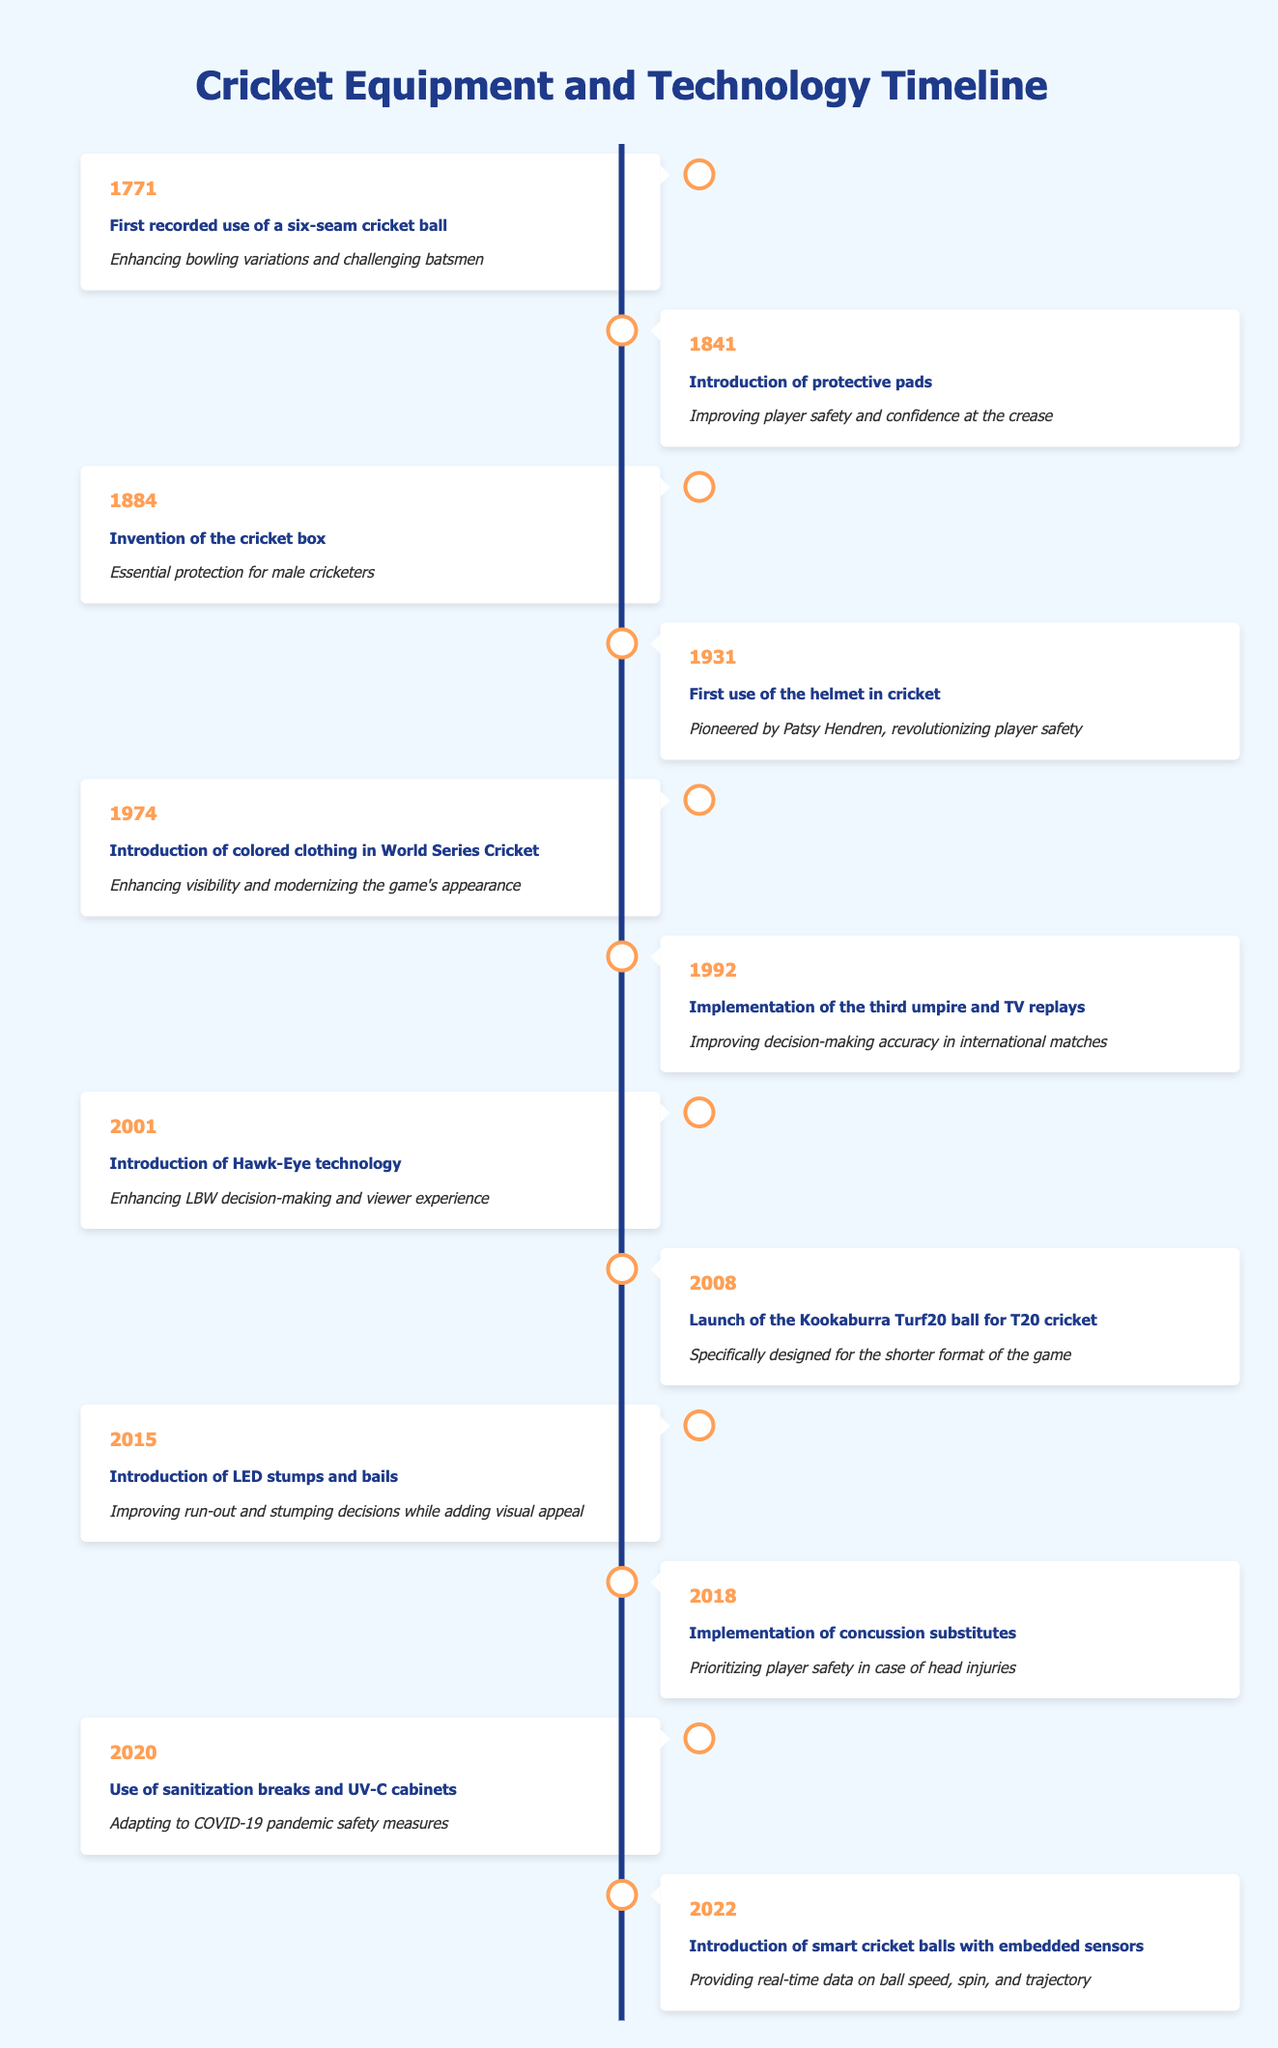What year was the first use of the helmet in cricket? The first use of the helmet in cricket is listed under the year 1931 in the timeline.
Answer: 1931 What protective gear was introduced in 1841? In the year 1841, the introduction of protective pads is mentioned in the timeline.
Answer: Protective pads How many years were between the first use of a six-seam cricket ball and the invention of the cricket box? The first recorded use of a six-seam cricket ball was in 1771, and the invention of the cricket box was in 1884. The difference is 1884 - 1771 = 113 years.
Answer: 113 years Did the implementation of the third umpire and TV replays occur before or after 2000? According to the table, the implementation of the third umpire and TV replays occurred in 1992, which is before the year 2000.
Answer: Before What major technological advancement was made in 2001, and what was its impact? The major technological advancement made in 2001 was the introduction of Hawk-Eye technology, which enhanced LBW decision-making and viewer experience.
Answer: Hawk-Eye technology How many significant advancements in cricket equipment occurred before 2000? The events listed before 2000 are from 1771 to 1992, making a total of 6 significant advancements: 1771, 1841, 1884, 1931, 1974, and 1992.
Answer: 6 Was the Kookaburra Turf20 ball designed for longer formats of the game? The Kookaburra Turf20 ball was specifically designed for T20 cricket, which is a shorter format, so the statement is false.
Answer: No What is the significance of the introduction of LED stumps and bails in 2015? The introduction of LED stumps and bails in 2015 improved run-out and stumping decisions, while also adding visual appeal to the game.
Answer: Improved decision-making and visual appeal How did the introduction of concussion substitutes in 2018 reflect changes in player safety measures? The introduction of concussion substitutes in 2018 prioritized player safety in case of head injuries, showing a significant shift towards the health and well-being of players in cricket.
Answer: Prioritized player safety 